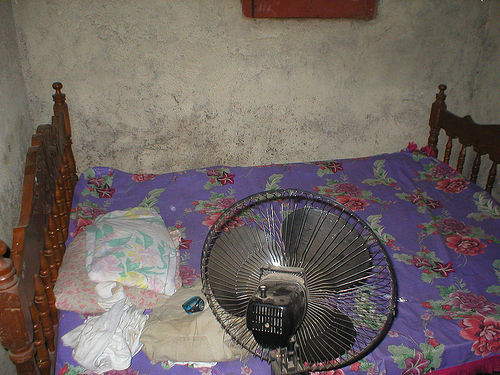<image>
Can you confirm if the fan is next to the blanket? No. The fan is not positioned next to the blanket. They are located in different areas of the scene. Is the table fan on the bed? No. The table fan is not positioned on the bed. They may be near each other, but the table fan is not supported by or resting on top of the bed. Is there a wood in front of the bed? No. The wood is not in front of the bed. The spatial positioning shows a different relationship between these objects. 